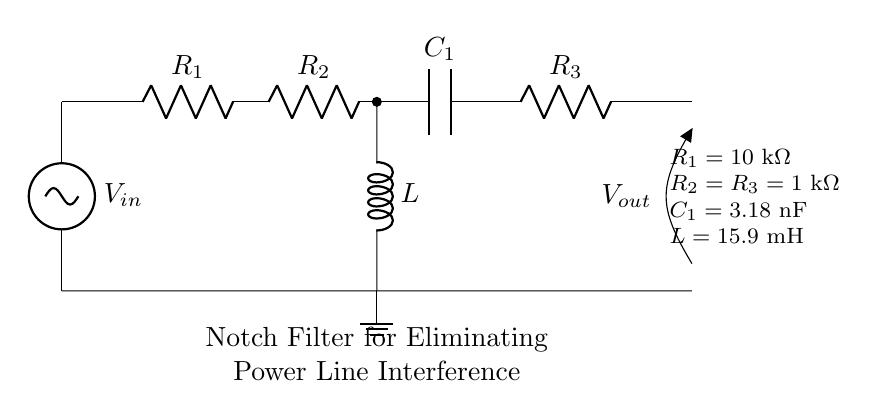What is the type of filter in this circuit? The circuit is designed as a notch filter, which is specifically used to eliminate a narrow band of frequencies, such as power line interference.
Answer: Notch filter What are the values of R2 and R3? The circuit diagram specifies that both R2 and R3 have the same value of 1 kΩ, as indicated in the component list.
Answer: 1 kΩ What is the value of C1? The component list indicates that C1, which is a capacitor in the circuit, has a value of 3.18 nF.
Answer: 3.18 nF Which component is in parallel with R2 and R3? The inductor L is in parallel with the combination of R2 and R3, as indicated by its connections in the diagram.
Answer: Inductor How does the notch filter affect the output voltage? The notch filter will attenuate the output voltage at its notch frequency, which corresponds to the power line frequency, effectively reducing interference.
Answer: Attenuates What would happen if R1 is decreased? Decreasing R1 would increase the bandwidth of the filter, possibly affecting the effectiveness of eliminating power line interference.
Answer: Increases bandwidth What is the function of the inductor in this circuit? In this notch filter, the inductor is used to create a resonant circuit with the capacitors, helping to provide the necessary attenuation at the notch frequency.
Answer: Provide resonance 